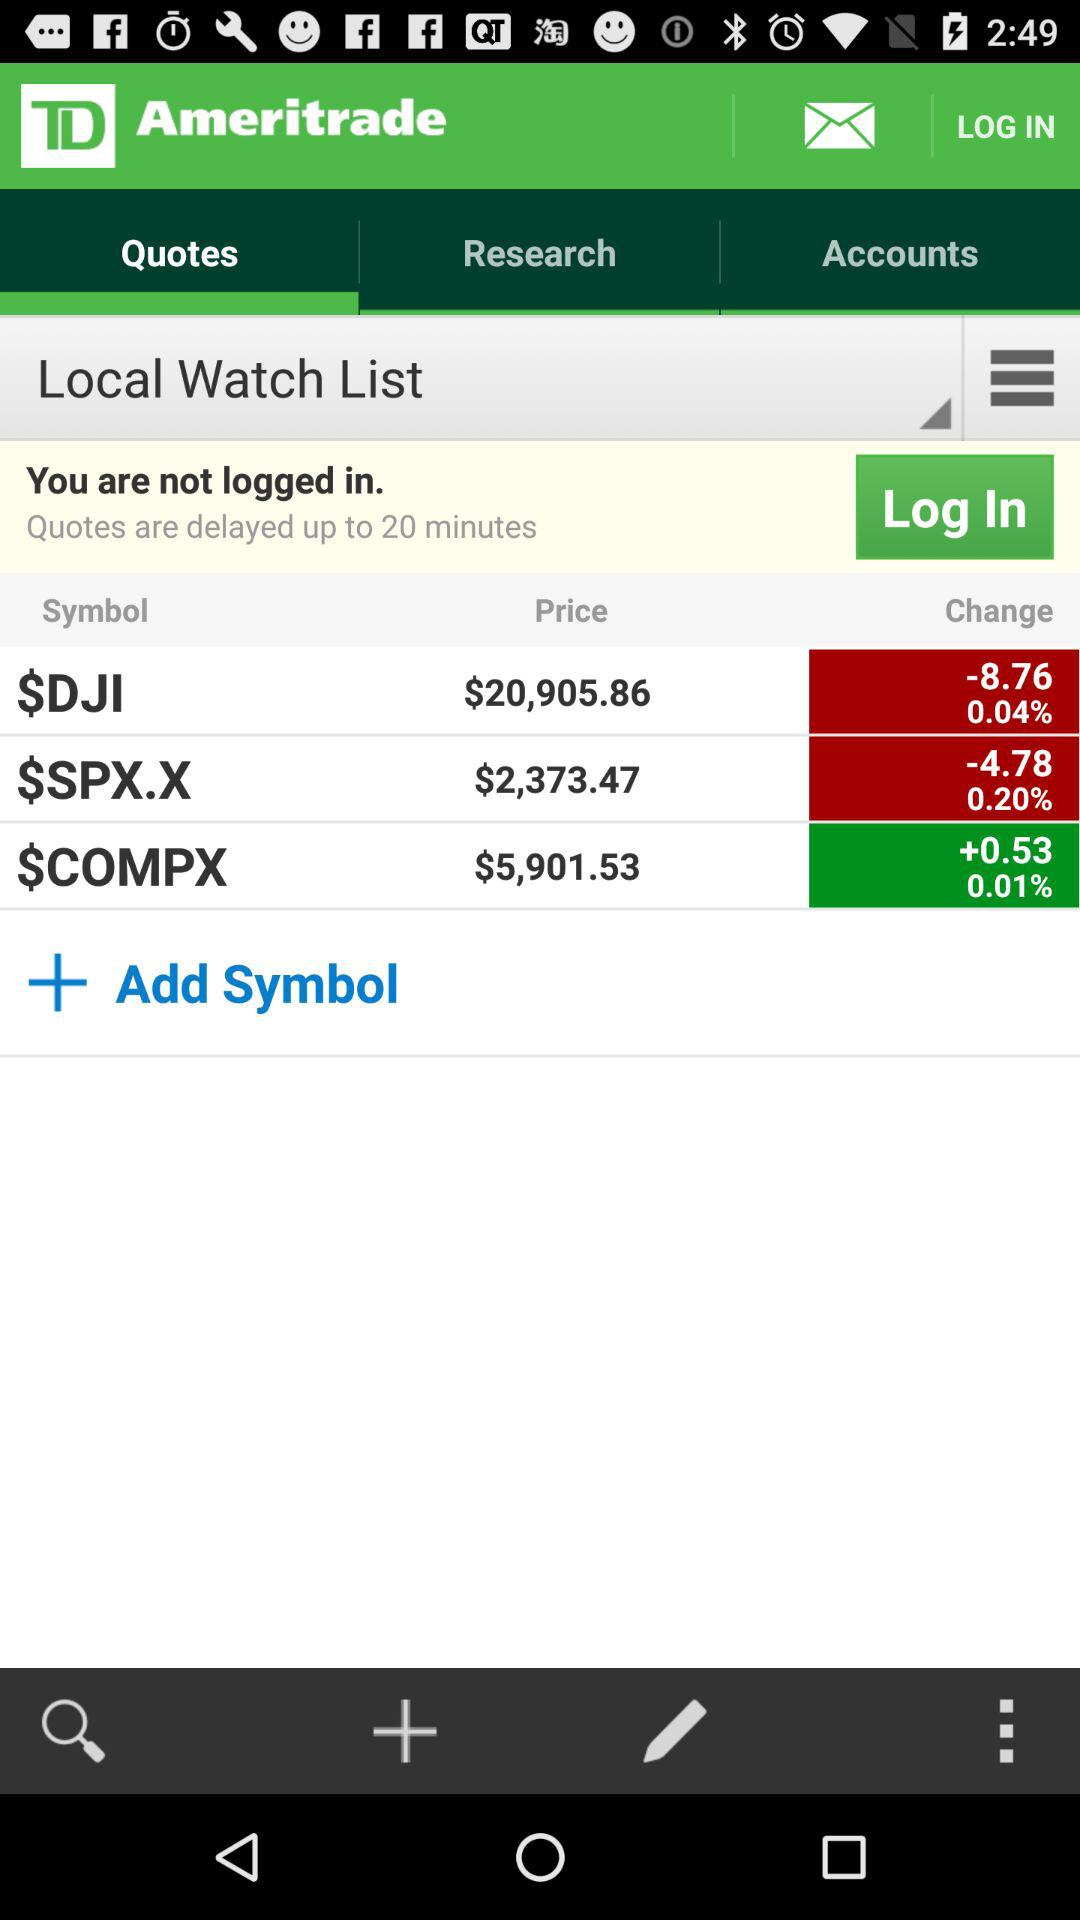What is the price of $SPX.X? The price is $2,373.47. 